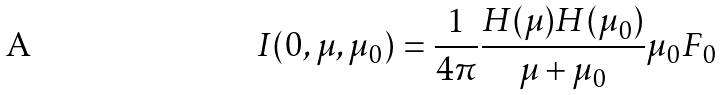<formula> <loc_0><loc_0><loc_500><loc_500>I ( 0 , \mu , \mu _ { 0 } ) = \frac { 1 } { 4 \pi } \frac { H ( \mu ) H ( \mu _ { 0 } ) } { \mu + \mu _ { 0 } } \mu _ { 0 } F _ { 0 }</formula> 